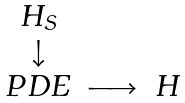Convert formula to latex. <formula><loc_0><loc_0><loc_500><loc_500>\left . \begin{array} { c c c } H _ { S } & & \\ \downarrow & & \\ P D E & \longrightarrow & H \end{array} \right .</formula> 